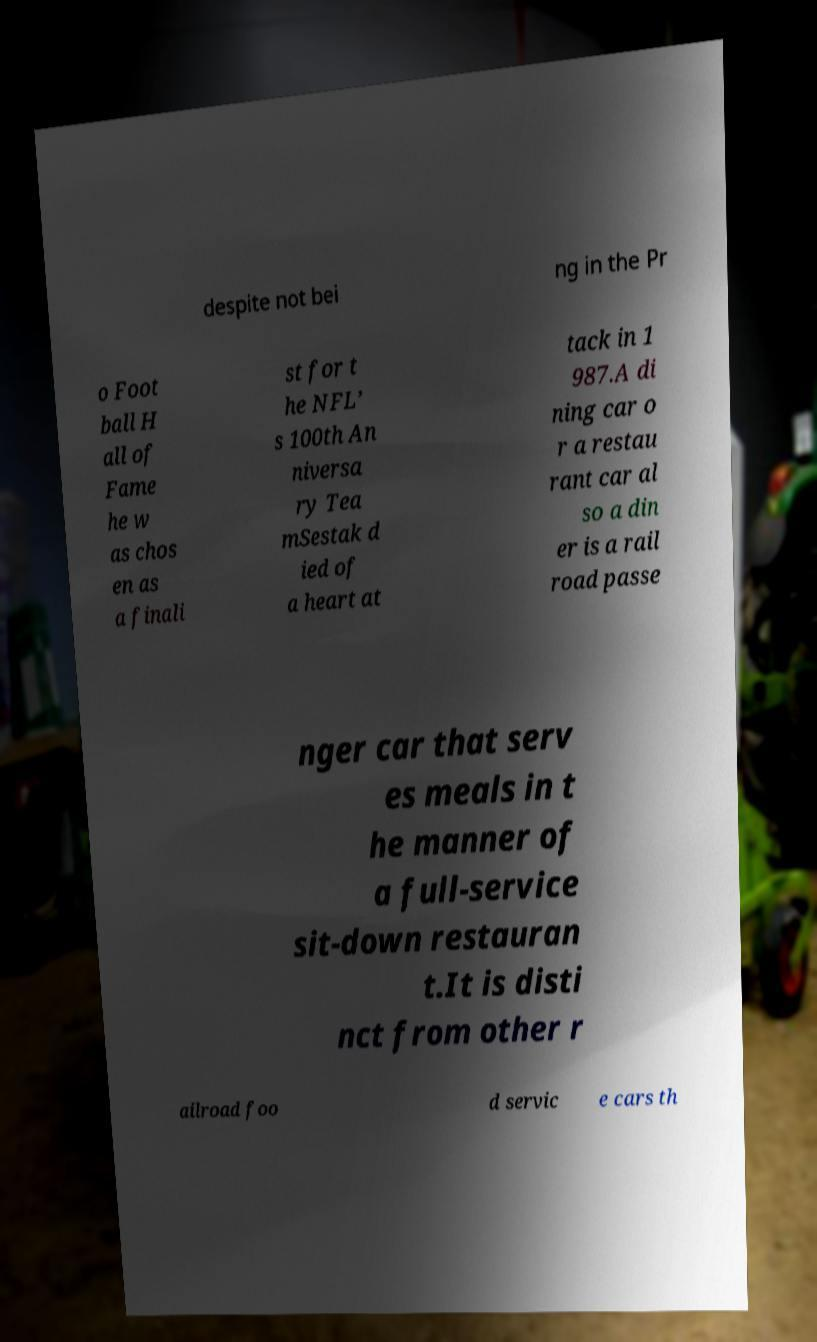Please read and relay the text visible in this image. What does it say? despite not bei ng in the Pr o Foot ball H all of Fame he w as chos en as a finali st for t he NFL’ s 100th An niversa ry Tea mSestak d ied of a heart at tack in 1 987.A di ning car o r a restau rant car al so a din er is a rail road passe nger car that serv es meals in t he manner of a full-service sit-down restauran t.It is disti nct from other r ailroad foo d servic e cars th 